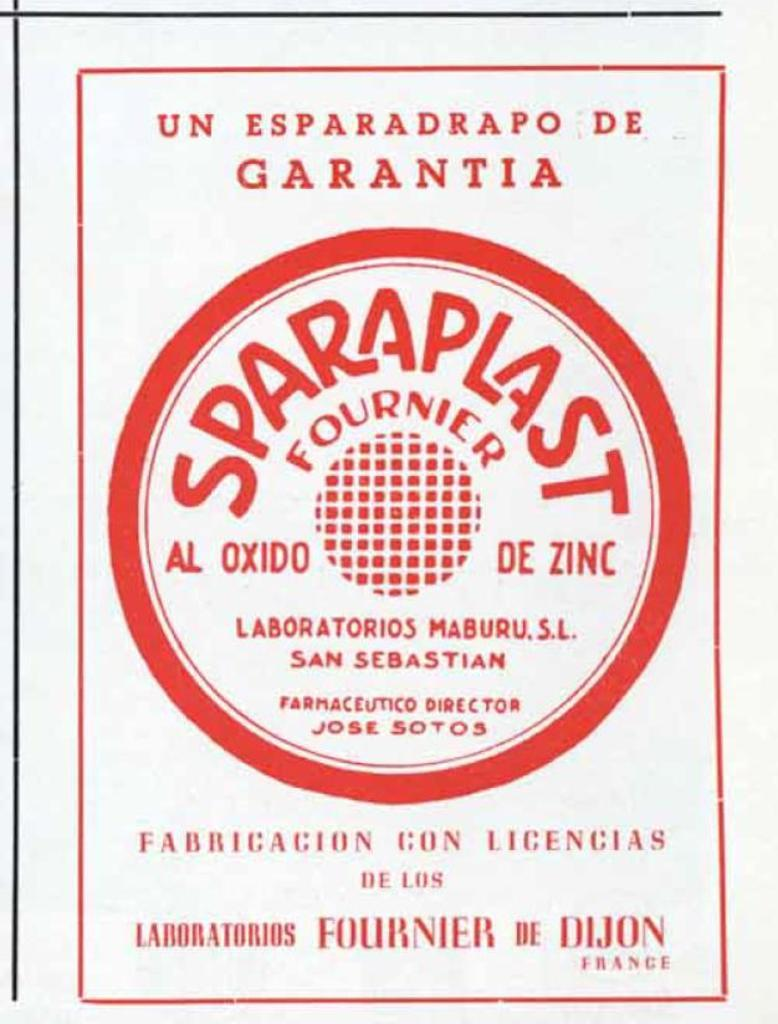What is present in the image that contains information or a message? There is a poster in the image. Can you describe the text on the poster? There is writing on the poster. What type of wire is being used by the grandmother in the image? There is no grandmother or wire present in the image; it only features a poster with writing on it. 